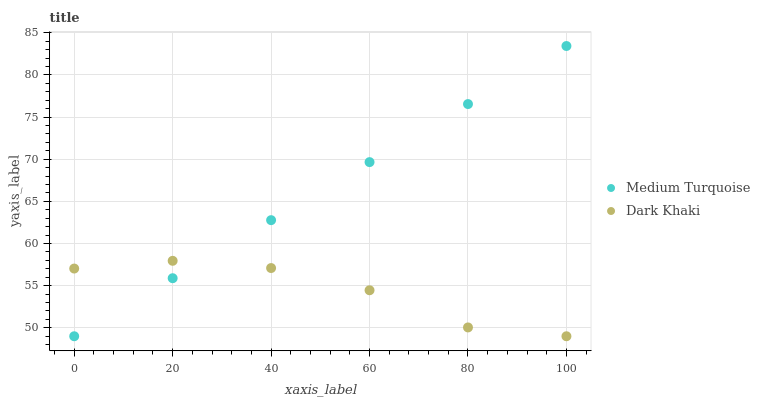Does Dark Khaki have the minimum area under the curve?
Answer yes or no. Yes. Does Medium Turquoise have the maximum area under the curve?
Answer yes or no. Yes. Does Medium Turquoise have the minimum area under the curve?
Answer yes or no. No. Is Medium Turquoise the smoothest?
Answer yes or no. Yes. Is Dark Khaki the roughest?
Answer yes or no. Yes. Is Medium Turquoise the roughest?
Answer yes or no. No. Does Dark Khaki have the lowest value?
Answer yes or no. Yes. Does Medium Turquoise have the highest value?
Answer yes or no. Yes. Does Dark Khaki intersect Medium Turquoise?
Answer yes or no. Yes. Is Dark Khaki less than Medium Turquoise?
Answer yes or no. No. Is Dark Khaki greater than Medium Turquoise?
Answer yes or no. No. 